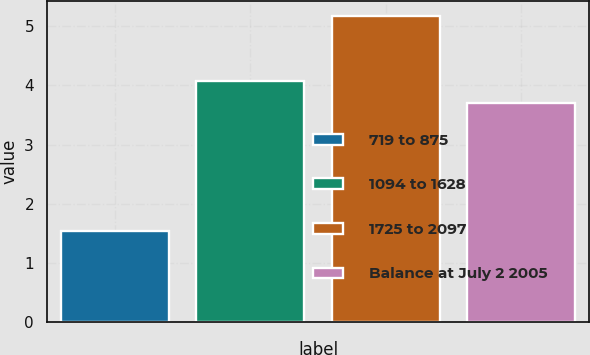Convert chart. <chart><loc_0><loc_0><loc_500><loc_500><bar_chart><fcel>719 to 875<fcel>1094 to 1628<fcel>1725 to 2097<fcel>Balance at July 2 2005<nl><fcel>1.54<fcel>4.07<fcel>5.17<fcel>3.71<nl></chart> 